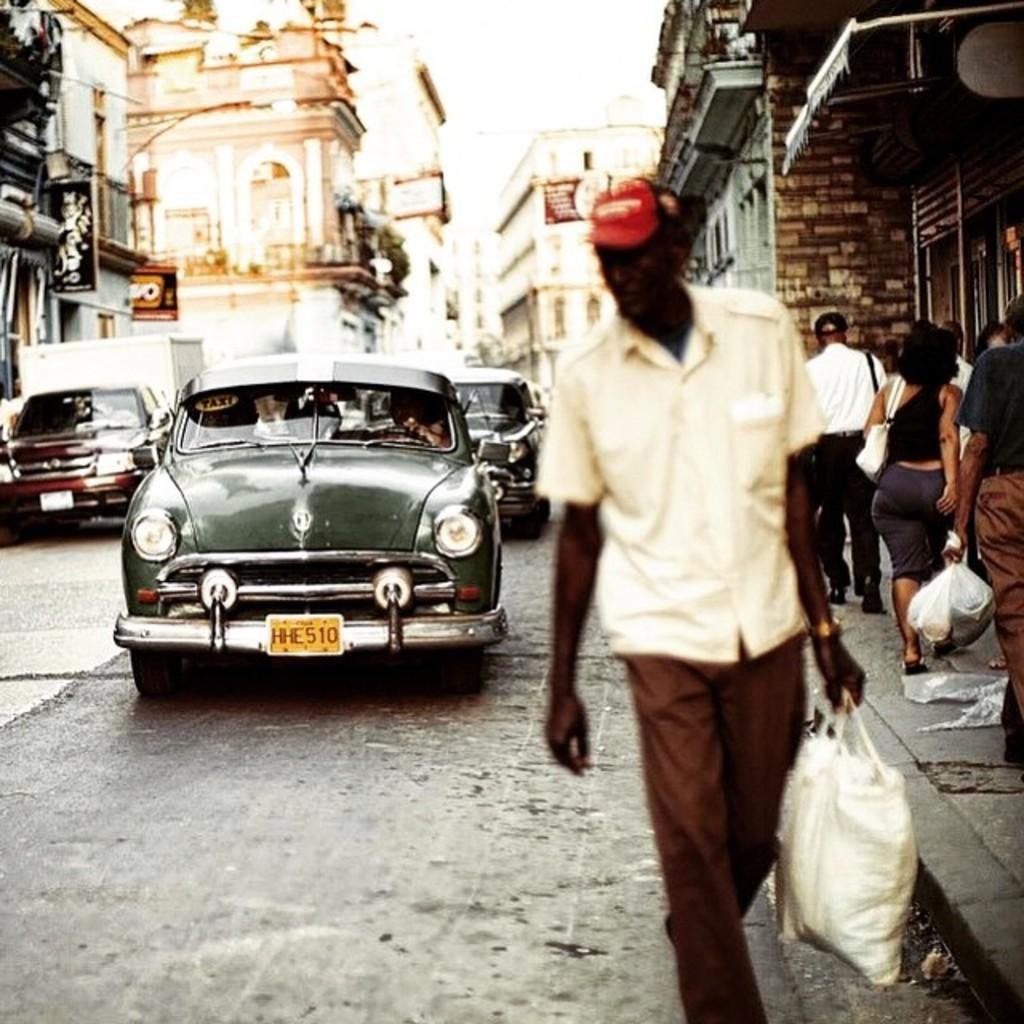What are the people in the image doing? The people in the image are walking on the sidewalk. What else can be seen on the road besides the people? There are vehicles present on the road. What type of structures are visible in the image? There are buildings present in the image. What type of grain is being harvested in the image? There is no grain present in the image; it features people walking on the sidewalk and vehicles on the road. What is the comb used for in the image? There is no comb present in the image. 